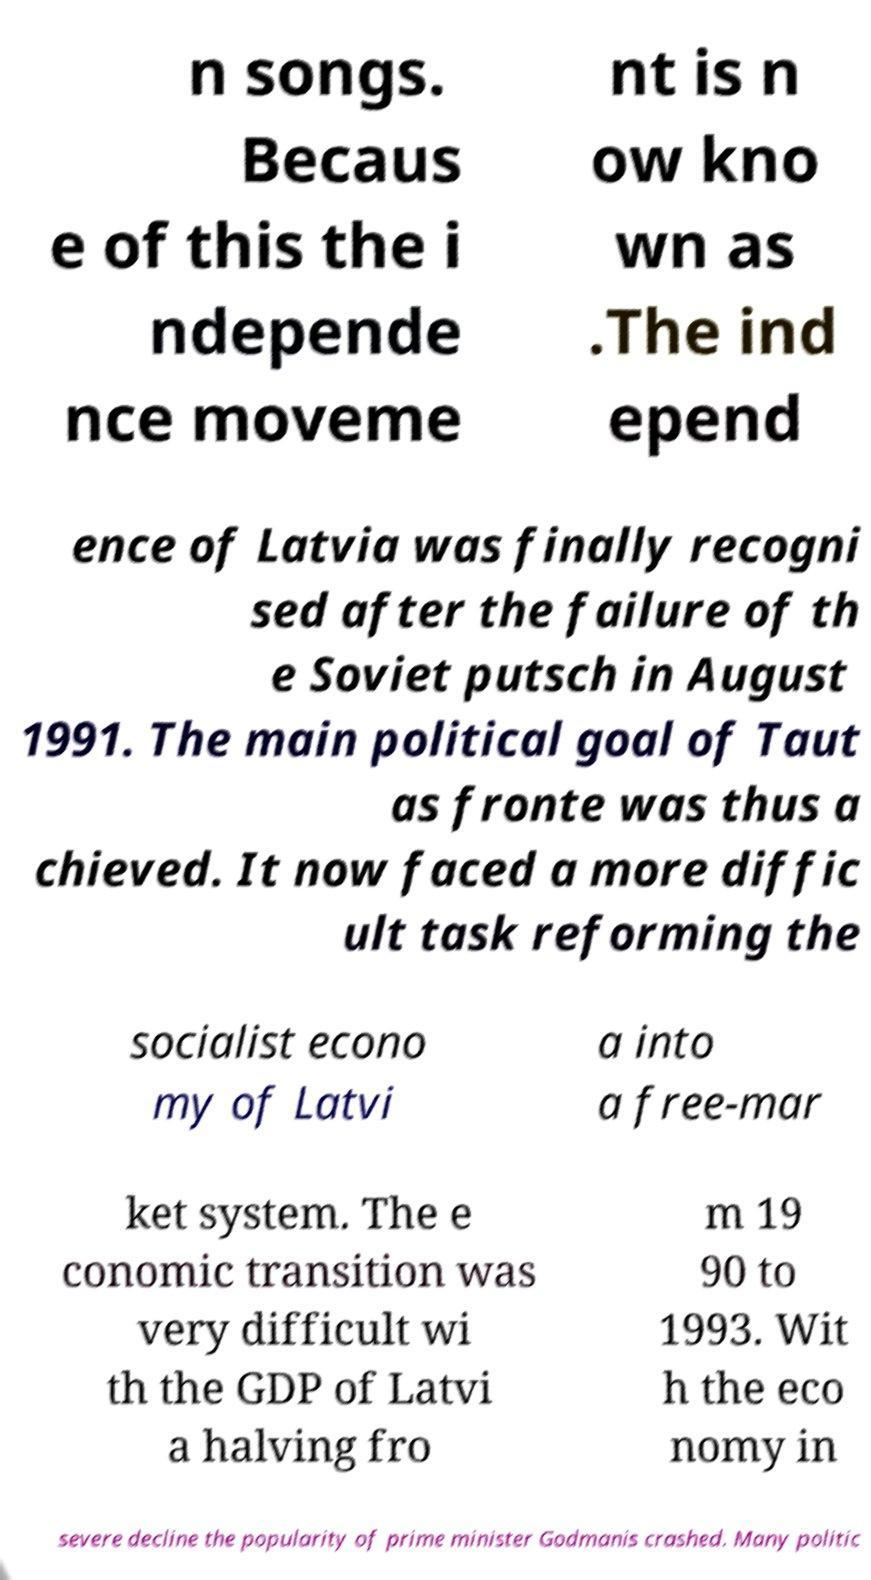Could you extract and type out the text from this image? n songs. Becaus e of this the i ndepende nce moveme nt is n ow kno wn as .The ind epend ence of Latvia was finally recogni sed after the failure of th e Soviet putsch in August 1991. The main political goal of Taut as fronte was thus a chieved. It now faced a more diffic ult task reforming the socialist econo my of Latvi a into a free-mar ket system. The e conomic transition was very difficult wi th the GDP of Latvi a halving fro m 19 90 to 1993. Wit h the eco nomy in severe decline the popularity of prime minister Godmanis crashed. Many politic 